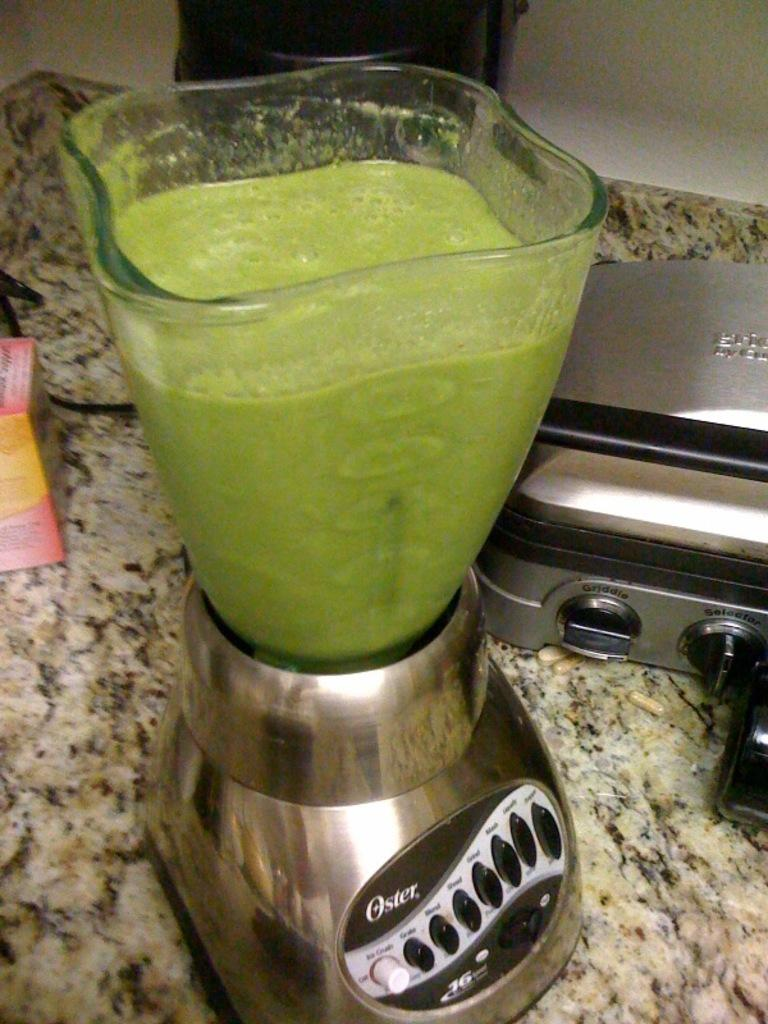Provide a one-sentence caption for the provided image. An Oster blender has been used to make a green juice. 